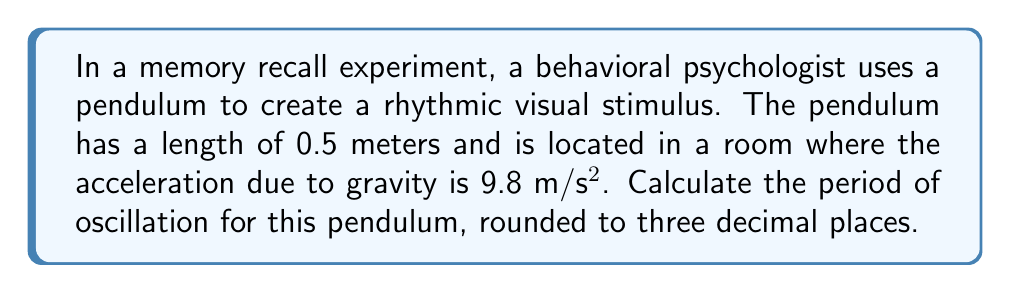Provide a solution to this math problem. To solve this problem, we'll use the formula for the period of a simple pendulum:

$$T = 2\pi \sqrt{\frac{L}{g}}$$

Where:
$T$ = period of oscillation (in seconds)
$L$ = length of the pendulum (in meters)
$g$ = acceleration due to gravity (in m/s²)

Given:
$L = 0.5$ m
$g = 9.8$ m/s²

Let's substitute these values into the formula:

$$T = 2\pi \sqrt{\frac{0.5}{9.8}}$$

Now, let's solve step-by-step:

1) First, calculate the fraction inside the square root:
   $$\frac{0.5}{9.8} \approx 0.05102$$

2) Take the square root of this value:
   $$\sqrt{0.05102} \approx 0.22587$$

3) Multiply by $2\pi$:
   $$2\pi * 0.22587 \approx 1.41867$$

4) Round to three decimal places:
   $$1.419 \text{ seconds}$$

Therefore, the period of oscillation for the pendulum is approximately 1.419 seconds.
Answer: $1.419$ s 